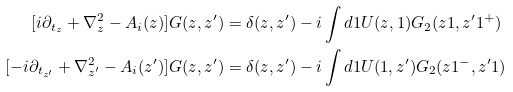<formula> <loc_0><loc_0><loc_500><loc_500>[ i \partial _ { t _ { z } } + \nabla ^ { 2 } _ { z } - A _ { i } ( z ) ] G ( z , z ^ { \prime } ) & = \delta ( z , z ^ { \prime } ) - i \int d 1 U ( z , 1 ) G _ { 2 } ( z 1 , z ^ { \prime } 1 ^ { + } ) \\ [ - i \partial _ { t _ { z ^ { \prime } } } + \nabla ^ { 2 } _ { z ^ { \prime } } - A _ { i } ( z ^ { \prime } ) ] G ( z , z ^ { \prime } ) & = \delta ( z , z ^ { \prime } ) - i \int d 1 U ( 1 , z ^ { \prime } ) G _ { 2 } ( z 1 ^ { - } , z ^ { \prime } 1 )</formula> 